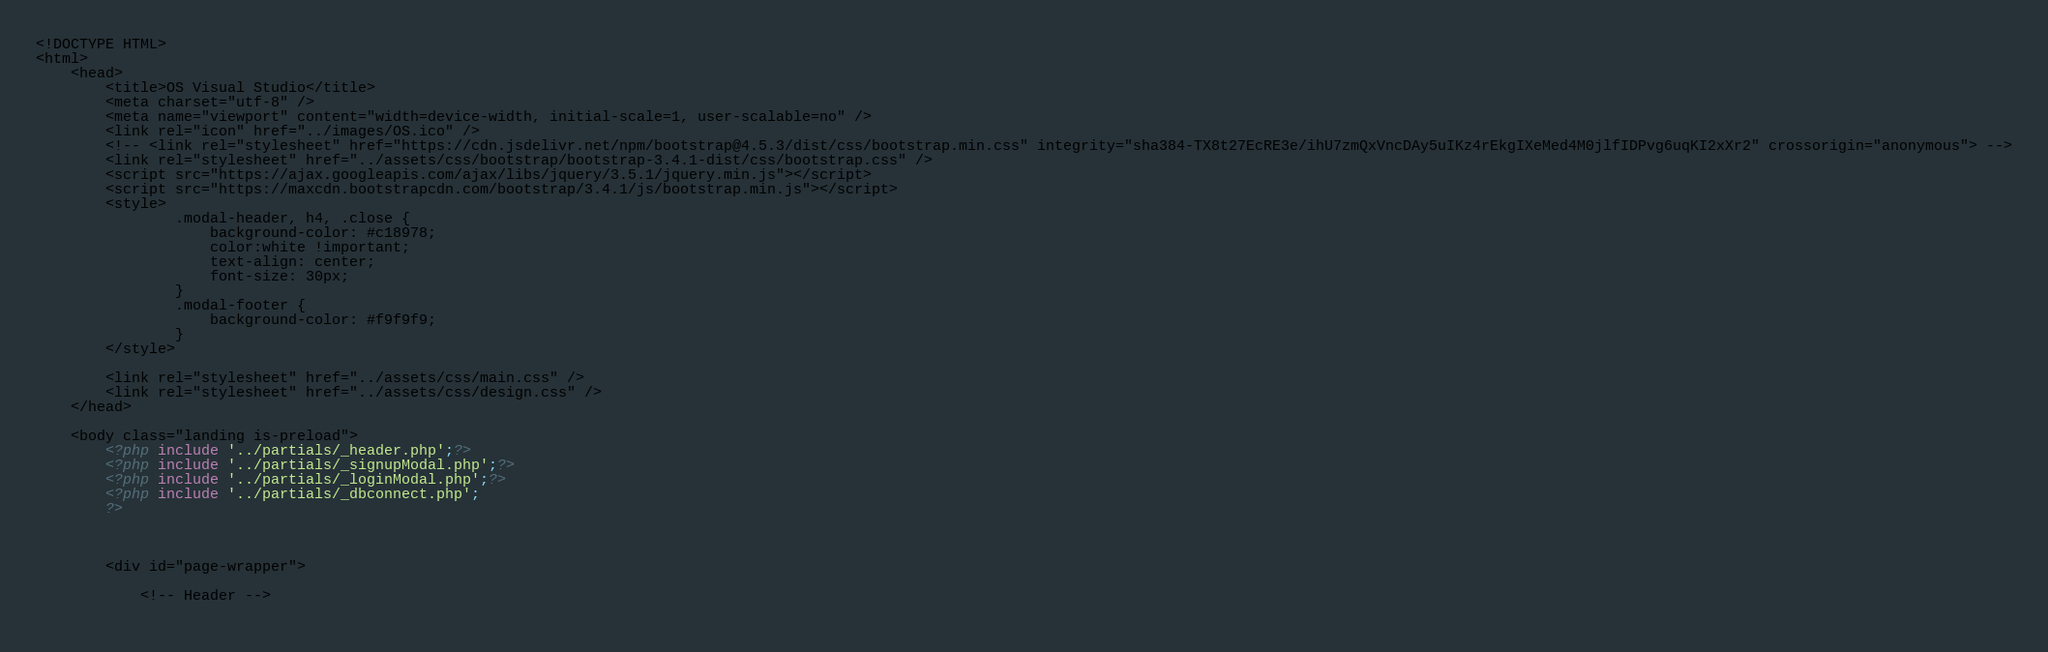Convert code to text. <code><loc_0><loc_0><loc_500><loc_500><_PHP_><!DOCTYPE HTML>
<html>
	<head>
		<title>OS Visual Studio</title>
		<meta charset="utf-8" />
		<meta name="viewport" content="width=device-width, initial-scale=1, user-scalable=no" />
		<link rel="icon" href="../images/OS.ico" />
		<!-- <link rel="stylesheet" href="https://cdn.jsdelivr.net/npm/bootstrap@4.5.3/dist/css/bootstrap.min.css" integrity="sha384-TX8t27EcRE3e/ihU7zmQxVncDAy5uIKz4rEkgIXeMed4M0jlfIDPvg6uqKI2xXr2" crossorigin="anonymous"> -->
		<link rel="stylesheet" href="../assets/css/bootstrap/bootstrap-3.4.1-dist/css/bootstrap.css" />
   		<script src="https://ajax.googleapis.com/ajax/libs/jquery/3.5.1/jquery.min.js"></script>
  		<script src="https://maxcdn.bootstrapcdn.com/bootstrap/3.4.1/js/bootstrap.min.js"></script> 
		<style>
  				.modal-header, h4, .close {
    				background-color: #c18978;
    				color:white !important;
    				text-align: center;
    				font-size: 30px;
  				}
  				.modal-footer {
    				background-color: #f9f9f9;
  				}
  		</style>

		<link rel="stylesheet" href="../assets/css/main.css" />
		<link rel="stylesheet" href="../assets/css/design.css" />
	</head>

	<body class="landing is-preload">
		<?php include '../partials/_header.php';?>
		<?php include '../partials/_signupModal.php';?>
		<?php include '../partials/_loginModal.php';?>
		<?php include '../partials/_dbconnect.php';
		?>



		<div id="page-wrapper">

			<!-- Header -->
			</code> 